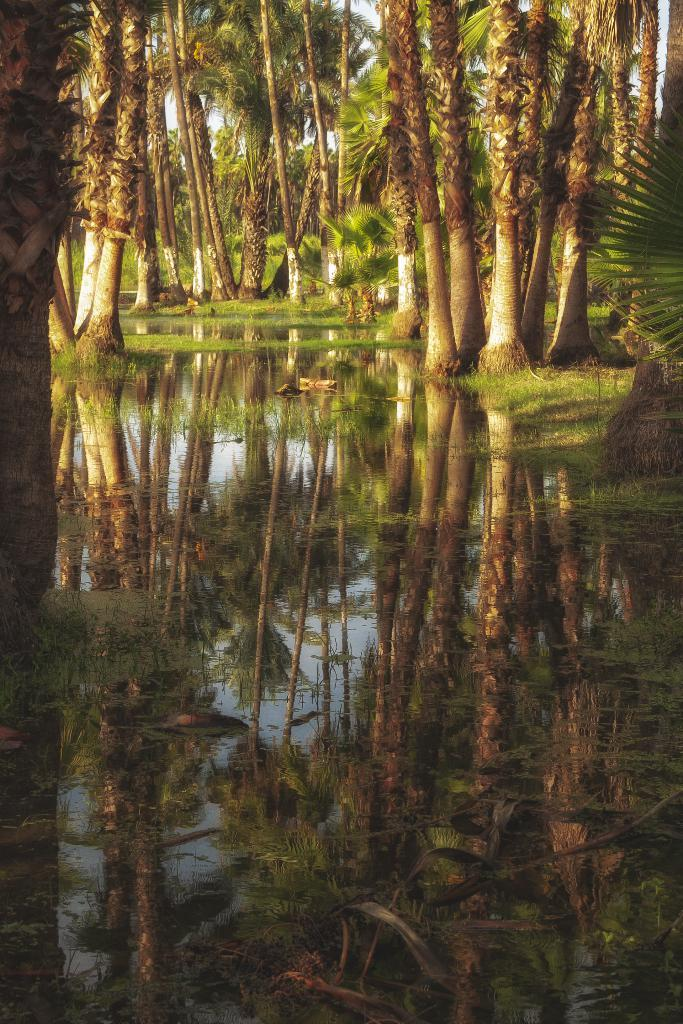What is visible in the image? Water, trees, and the sky are visible in the image. Can you describe the natural setting in the image? The natural setting includes water and trees. What is visible in the background of the image? The sky is visible in the background of the image. Where is the store located in the image? There is no store present in the image. Is the person's brother visible in the image? There is no person or brother present in the image. 